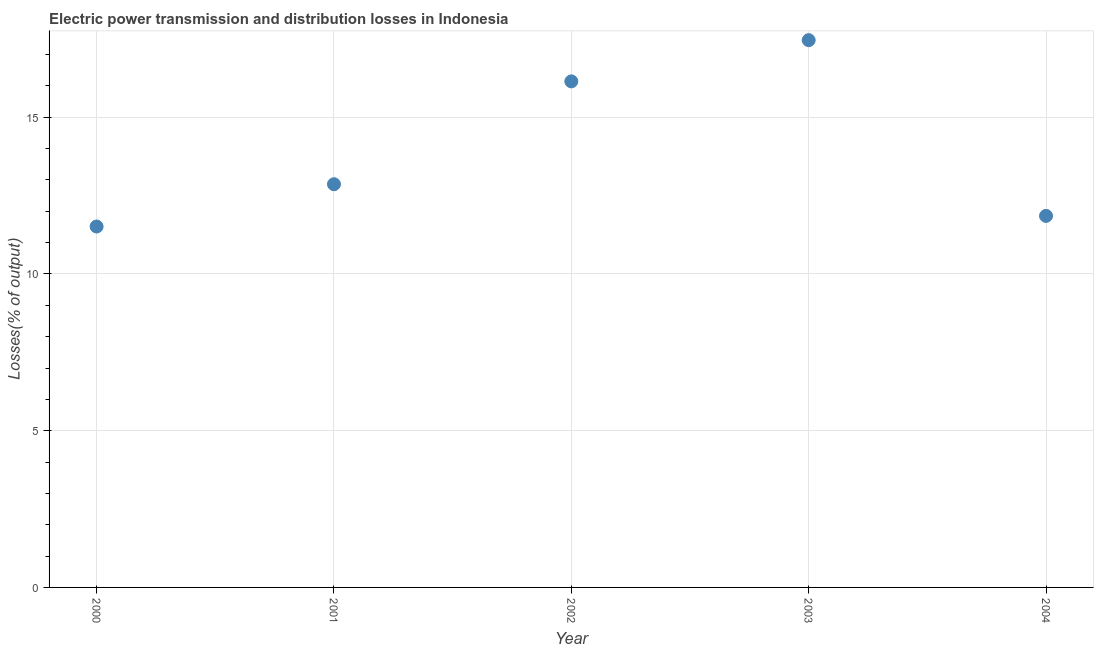What is the electric power transmission and distribution losses in 2000?
Keep it short and to the point. 11.51. Across all years, what is the maximum electric power transmission and distribution losses?
Your answer should be very brief. 17.46. Across all years, what is the minimum electric power transmission and distribution losses?
Give a very brief answer. 11.51. In which year was the electric power transmission and distribution losses maximum?
Your response must be concise. 2003. What is the sum of the electric power transmission and distribution losses?
Keep it short and to the point. 69.83. What is the difference between the electric power transmission and distribution losses in 2000 and 2002?
Your answer should be compact. -4.63. What is the average electric power transmission and distribution losses per year?
Keep it short and to the point. 13.97. What is the median electric power transmission and distribution losses?
Your answer should be compact. 12.86. What is the ratio of the electric power transmission and distribution losses in 2001 to that in 2004?
Provide a succinct answer. 1.09. Is the electric power transmission and distribution losses in 2002 less than that in 2004?
Offer a very short reply. No. Is the difference between the electric power transmission and distribution losses in 2001 and 2004 greater than the difference between any two years?
Make the answer very short. No. What is the difference between the highest and the second highest electric power transmission and distribution losses?
Offer a very short reply. 1.31. What is the difference between the highest and the lowest electric power transmission and distribution losses?
Provide a short and direct response. 5.95. In how many years, is the electric power transmission and distribution losses greater than the average electric power transmission and distribution losses taken over all years?
Offer a very short reply. 2. Does the electric power transmission and distribution losses monotonically increase over the years?
Ensure brevity in your answer.  No. How many dotlines are there?
Provide a succinct answer. 1. How many years are there in the graph?
Keep it short and to the point. 5. Does the graph contain any zero values?
Offer a terse response. No. What is the title of the graph?
Provide a succinct answer. Electric power transmission and distribution losses in Indonesia. What is the label or title of the X-axis?
Your answer should be compact. Year. What is the label or title of the Y-axis?
Ensure brevity in your answer.  Losses(% of output). What is the Losses(% of output) in 2000?
Your response must be concise. 11.51. What is the Losses(% of output) in 2001?
Ensure brevity in your answer.  12.86. What is the Losses(% of output) in 2002?
Your answer should be very brief. 16.14. What is the Losses(% of output) in 2003?
Your response must be concise. 17.46. What is the Losses(% of output) in 2004?
Keep it short and to the point. 11.85. What is the difference between the Losses(% of output) in 2000 and 2001?
Your answer should be compact. -1.35. What is the difference between the Losses(% of output) in 2000 and 2002?
Keep it short and to the point. -4.63. What is the difference between the Losses(% of output) in 2000 and 2003?
Offer a terse response. -5.95. What is the difference between the Losses(% of output) in 2000 and 2004?
Offer a very short reply. -0.34. What is the difference between the Losses(% of output) in 2001 and 2002?
Your answer should be compact. -3.28. What is the difference between the Losses(% of output) in 2001 and 2003?
Offer a very short reply. -4.6. What is the difference between the Losses(% of output) in 2001 and 2004?
Make the answer very short. 1.01. What is the difference between the Losses(% of output) in 2002 and 2003?
Give a very brief answer. -1.31. What is the difference between the Losses(% of output) in 2002 and 2004?
Your answer should be very brief. 4.29. What is the difference between the Losses(% of output) in 2003 and 2004?
Your response must be concise. 5.61. What is the ratio of the Losses(% of output) in 2000 to that in 2001?
Offer a terse response. 0.9. What is the ratio of the Losses(% of output) in 2000 to that in 2002?
Make the answer very short. 0.71. What is the ratio of the Losses(% of output) in 2000 to that in 2003?
Provide a succinct answer. 0.66. What is the ratio of the Losses(% of output) in 2001 to that in 2002?
Offer a very short reply. 0.8. What is the ratio of the Losses(% of output) in 2001 to that in 2003?
Your answer should be compact. 0.74. What is the ratio of the Losses(% of output) in 2001 to that in 2004?
Offer a very short reply. 1.08. What is the ratio of the Losses(% of output) in 2002 to that in 2003?
Your answer should be very brief. 0.93. What is the ratio of the Losses(% of output) in 2002 to that in 2004?
Your answer should be very brief. 1.36. What is the ratio of the Losses(% of output) in 2003 to that in 2004?
Give a very brief answer. 1.47. 